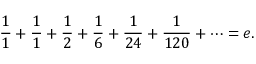<formula> <loc_0><loc_0><loc_500><loc_500>{ \frac { 1 } { 1 } } + { \frac { 1 } { 1 } } + { \frac { 1 } { 2 } } + { \frac { 1 } { 6 } } + { \frac { 1 } { 2 4 } } + { \frac { 1 } { 1 2 0 } } + \cdots = e .</formula> 